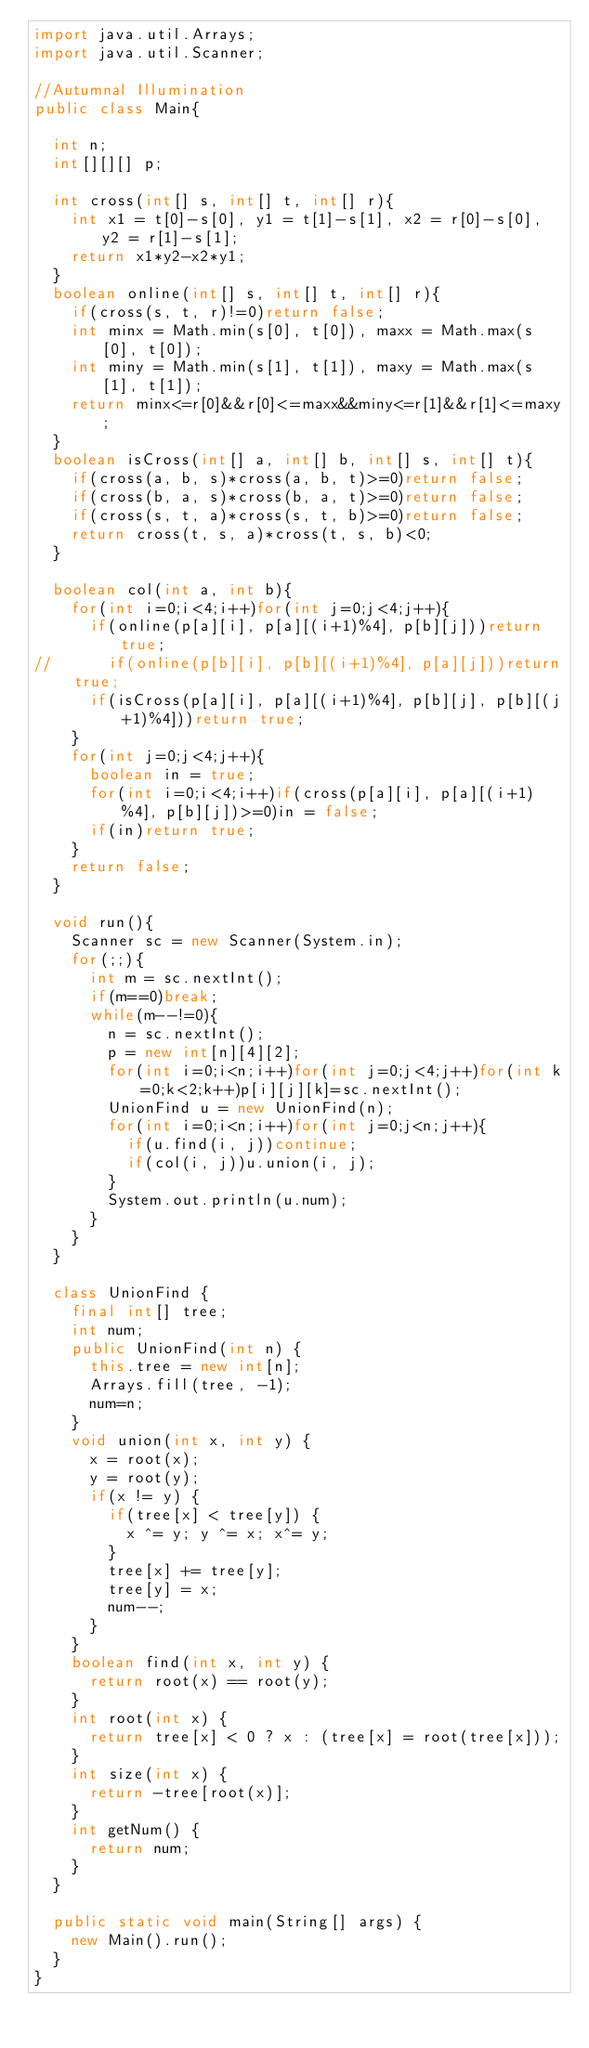Convert code to text. <code><loc_0><loc_0><loc_500><loc_500><_Java_>import java.util.Arrays;
import java.util.Scanner;

//Autumnal Illumination
public class Main{

	int n;
	int[][][] p;
	
	int cross(int[] s, int[] t, int[] r){
		int x1 = t[0]-s[0], y1 = t[1]-s[1], x2 = r[0]-s[0], y2 = r[1]-s[1];
		return x1*y2-x2*y1;
	}
	boolean online(int[] s, int[] t, int[] r){
		if(cross(s, t, r)!=0)return false;
		int minx = Math.min(s[0], t[0]), maxx = Math.max(s[0], t[0]);
		int miny = Math.min(s[1], t[1]), maxy = Math.max(s[1], t[1]);
		return minx<=r[0]&&r[0]<=maxx&&miny<=r[1]&&r[1]<=maxy;
	}
	boolean isCross(int[] a, int[] b, int[] s, int[] t){
		if(cross(a, b, s)*cross(a, b, t)>=0)return false;
		if(cross(b, a, s)*cross(b, a, t)>=0)return false;
		if(cross(s, t, a)*cross(s, t, b)>=0)return false;
		return cross(t, s, a)*cross(t, s, b)<0;
	}
	
	boolean col(int a, int b){
		for(int i=0;i<4;i++)for(int j=0;j<4;j++){
			if(online(p[a][i], p[a][(i+1)%4], p[b][j]))return true;
//			if(online(p[b][i], p[b][(i+1)%4], p[a][j]))return true;
			if(isCross(p[a][i], p[a][(i+1)%4], p[b][j], p[b][(j+1)%4]))return true;
		}
		for(int j=0;j<4;j++){
			boolean in = true;
			for(int i=0;i<4;i++)if(cross(p[a][i], p[a][(i+1)%4], p[b][j])>=0)in = false;
			if(in)return true;
		}
		return false;
	}
	
	void run(){
		Scanner sc = new Scanner(System.in);
		for(;;){
			int m = sc.nextInt();
			if(m==0)break;
			while(m--!=0){
				n = sc.nextInt();
				p = new int[n][4][2];
				for(int i=0;i<n;i++)for(int j=0;j<4;j++)for(int k=0;k<2;k++)p[i][j][k]=sc.nextInt();
				UnionFind u = new UnionFind(n);
				for(int i=0;i<n;i++)for(int j=0;j<n;j++){
					if(u.find(i, j))continue;
					if(col(i, j))u.union(i, j);
				}
				System.out.println(u.num);
			}
		}
	}
	
	class UnionFind {
		final int[] tree;
		int num;
		public UnionFind(int n) {
			this.tree = new int[n];
			Arrays.fill(tree, -1);
			num=n;
		}
		void union(int x, int y) {
			x = root(x);
			y = root(y);
			if(x != y) {
				if(tree[x] < tree[y]) {
					x ^= y; y ^= x; x^= y;
				}
				tree[x] += tree[y];
				tree[y] = x;
				num--;
			}
		}
		boolean find(int x, int y) {
			return root(x) == root(y);
		}
		int root(int x) {
			return tree[x] < 0 ? x : (tree[x] = root(tree[x]));
		}
		int size(int x) {
			return -tree[root(x)];
		}
		int getNum() {
			return num;
		}
	}
	
	public static void main(String[] args) {
		new Main().run();
	}
}</code> 